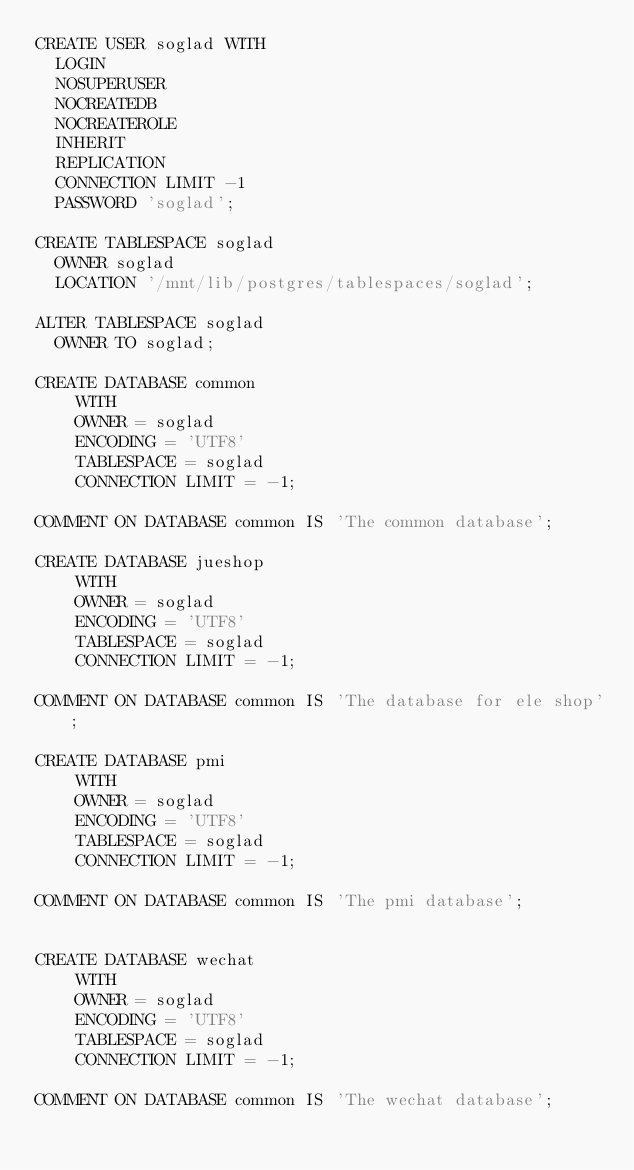<code> <loc_0><loc_0><loc_500><loc_500><_SQL_>CREATE USER soglad WITH
	LOGIN
	NOSUPERUSER
	NOCREATEDB
	NOCREATEROLE
	INHERIT
	REPLICATION
	CONNECTION LIMIT -1
	PASSWORD 'soglad';

CREATE TABLESPACE soglad
  OWNER soglad
  LOCATION '/mnt/lib/postgres/tablespaces/soglad';

ALTER TABLESPACE soglad
  OWNER TO soglad;

CREATE DATABASE common
    WITH 
    OWNER = soglad
    ENCODING = 'UTF8'
    TABLESPACE = soglad
    CONNECTION LIMIT = -1;

COMMENT ON DATABASE common IS 'The common database';

CREATE DATABASE jueshop
    WITH
    OWNER = soglad
    ENCODING = 'UTF8'
    TABLESPACE = soglad
    CONNECTION LIMIT = -1;

COMMENT ON DATABASE common IS 'The database for ele shop';

CREATE DATABASE pmi
    WITH 
    OWNER = soglad
    ENCODING = 'UTF8'
    TABLESPACE = soglad
    CONNECTION LIMIT = -1;

COMMENT ON DATABASE common IS 'The pmi database';


CREATE DATABASE wechat
    WITH 
    OWNER = soglad
    ENCODING = 'UTF8'
    TABLESPACE = soglad
    CONNECTION LIMIT = -1;

COMMENT ON DATABASE common IS 'The wechat database';</code> 